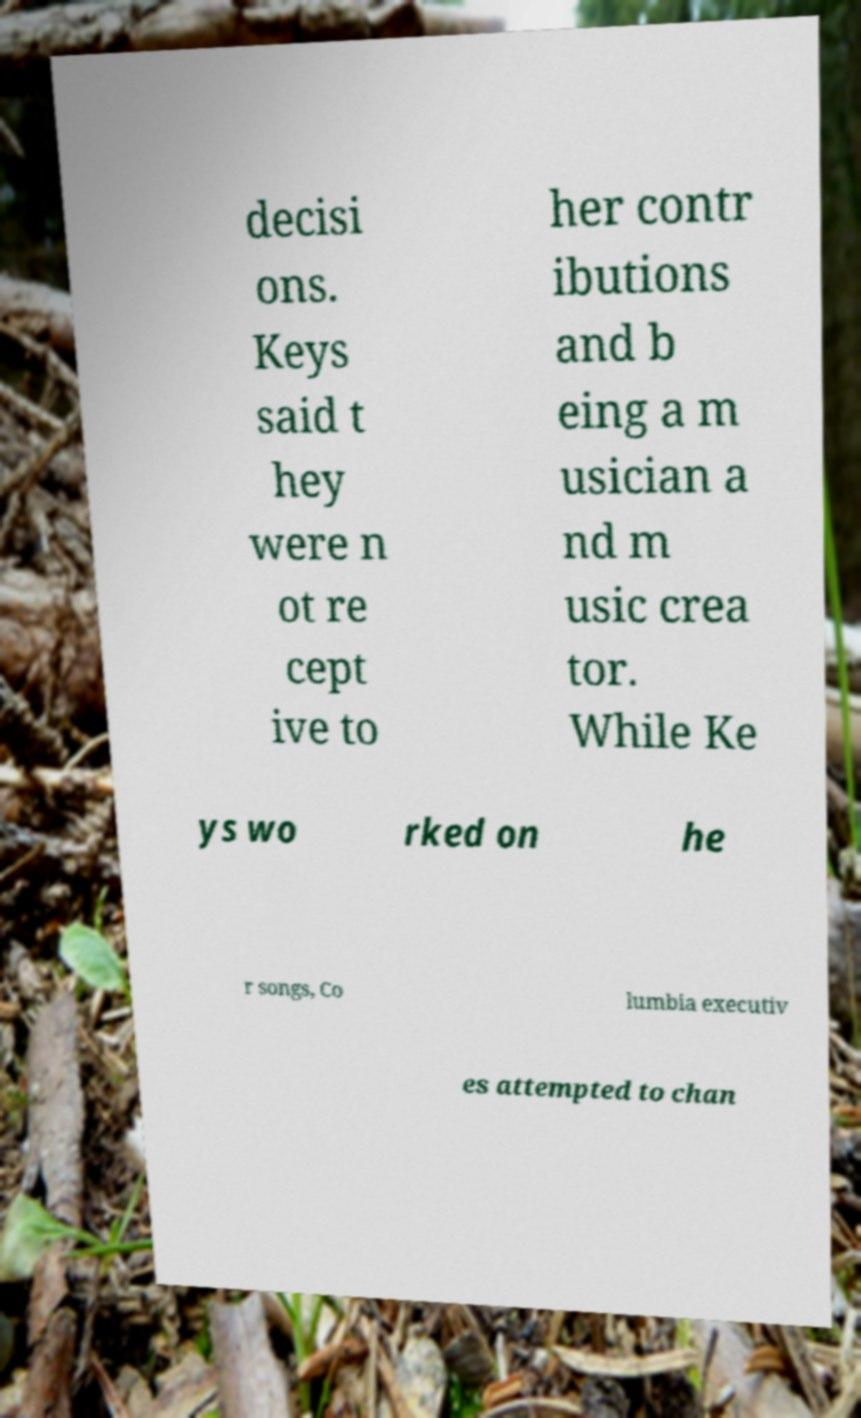For documentation purposes, I need the text within this image transcribed. Could you provide that? decisi ons. Keys said t hey were n ot re cept ive to her contr ibutions and b eing a m usician a nd m usic crea tor. While Ke ys wo rked on he r songs, Co lumbia executiv es attempted to chan 